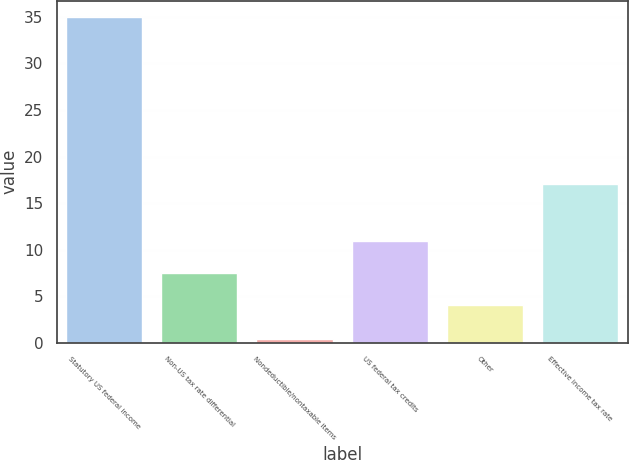Convert chart. <chart><loc_0><loc_0><loc_500><loc_500><bar_chart><fcel>Statutory US federal income<fcel>Non-US tax rate differential<fcel>Nondeductible/nontaxable items<fcel>US federal tax credits<fcel>Other<fcel>Effective income tax rate<nl><fcel>35<fcel>7.46<fcel>0.4<fcel>10.92<fcel>4<fcel>17.1<nl></chart> 